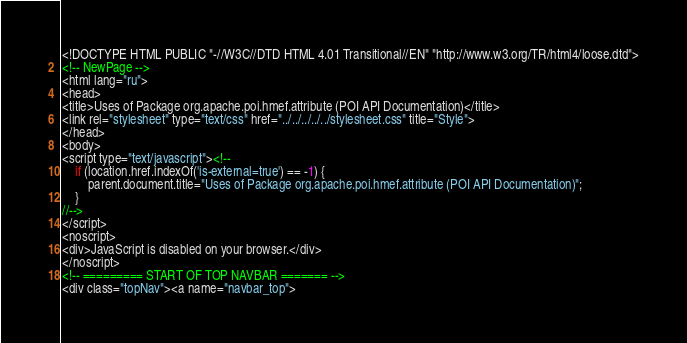<code> <loc_0><loc_0><loc_500><loc_500><_HTML_><!DOCTYPE HTML PUBLIC "-//W3C//DTD HTML 4.01 Transitional//EN" "http://www.w3.org/TR/html4/loose.dtd">
<!-- NewPage -->
<html lang="ru">
<head>
<title>Uses of Package org.apache.poi.hmef.attribute (POI API Documentation)</title>
<link rel="stylesheet" type="text/css" href="../../../../../stylesheet.css" title="Style">
</head>
<body>
<script type="text/javascript"><!--
    if (location.href.indexOf('is-external=true') == -1) {
        parent.document.title="Uses of Package org.apache.poi.hmef.attribute (POI API Documentation)";
    }
//-->
</script>
<noscript>
<div>JavaScript is disabled on your browser.</div>
</noscript>
<!-- ========= START OF TOP NAVBAR ======= -->
<div class="topNav"><a name="navbar_top"></code> 